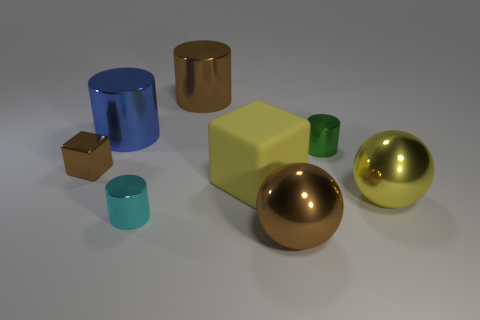What is the color of the small cylinder that is behind the small cyan cylinder?
Offer a terse response. Green. What number of other things are the same material as the small cyan cylinder?
Provide a short and direct response. 6. Is the number of small shiny cylinders that are in front of the yellow sphere greater than the number of cyan cylinders that are on the left side of the cyan shiny thing?
Your answer should be compact. Yes. There is a yellow metal sphere; what number of objects are to the left of it?
Keep it short and to the point. 7. Does the brown block have the same material as the big cylinder that is to the right of the large blue metal thing?
Make the answer very short. Yes. Does the tiny brown object have the same material as the big blue thing?
Make the answer very short. Yes. There is a shiny sphere that is to the left of the large yellow ball; is there a large brown object behind it?
Provide a short and direct response. Yes. What number of cylinders are in front of the matte object and behind the large yellow matte cube?
Make the answer very short. 0. What is the shape of the yellow thing behind the large yellow metal ball?
Provide a succinct answer. Cube. What number of yellow cubes have the same size as the blue cylinder?
Provide a short and direct response. 1. 